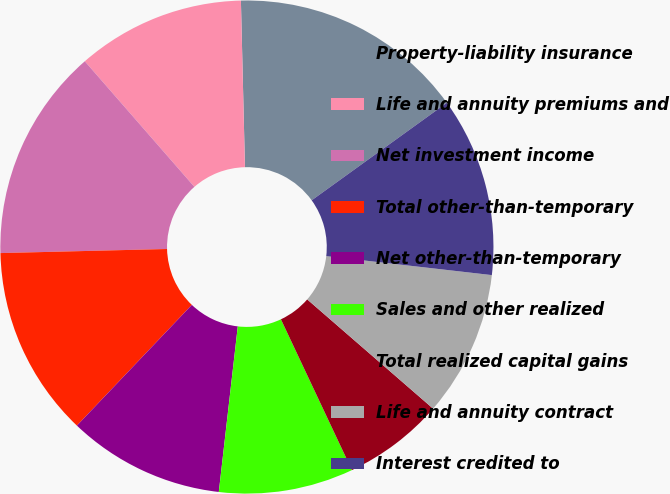<chart> <loc_0><loc_0><loc_500><loc_500><pie_chart><fcel>Property-liability insurance<fcel>Life and annuity premiums and<fcel>Net investment income<fcel>Total other-than-temporary<fcel>Net other-than-temporary<fcel>Sales and other realized<fcel>Total realized capital gains<fcel>Life and annuity contract<fcel>Interest credited to<nl><fcel>15.44%<fcel>11.03%<fcel>13.97%<fcel>12.5%<fcel>10.29%<fcel>8.82%<fcel>6.62%<fcel>9.56%<fcel>11.76%<nl></chart> 